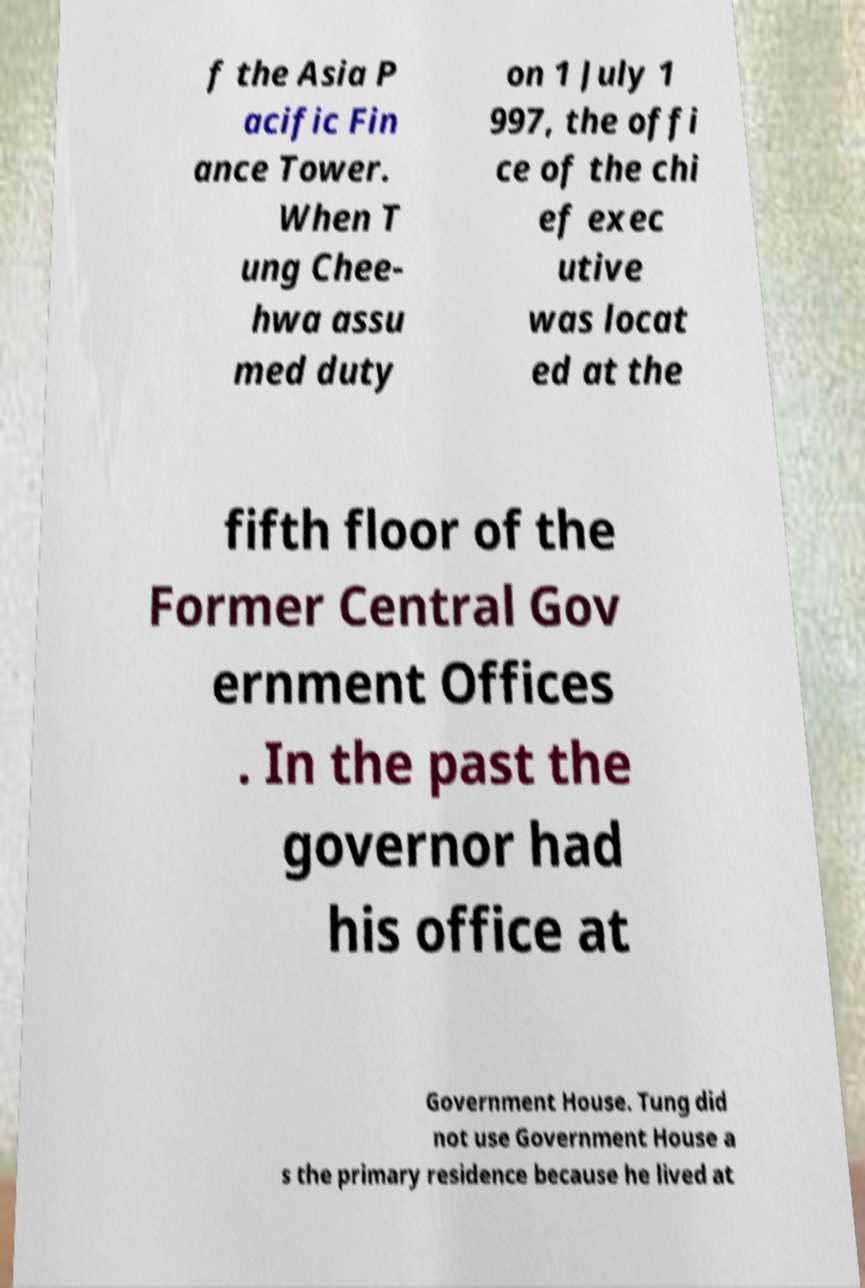Can you read and provide the text displayed in the image?This photo seems to have some interesting text. Can you extract and type it out for me? f the Asia P acific Fin ance Tower. When T ung Chee- hwa assu med duty on 1 July 1 997, the offi ce of the chi ef exec utive was locat ed at the fifth floor of the Former Central Gov ernment Offices . In the past the governor had his office at Government House. Tung did not use Government House a s the primary residence because he lived at 